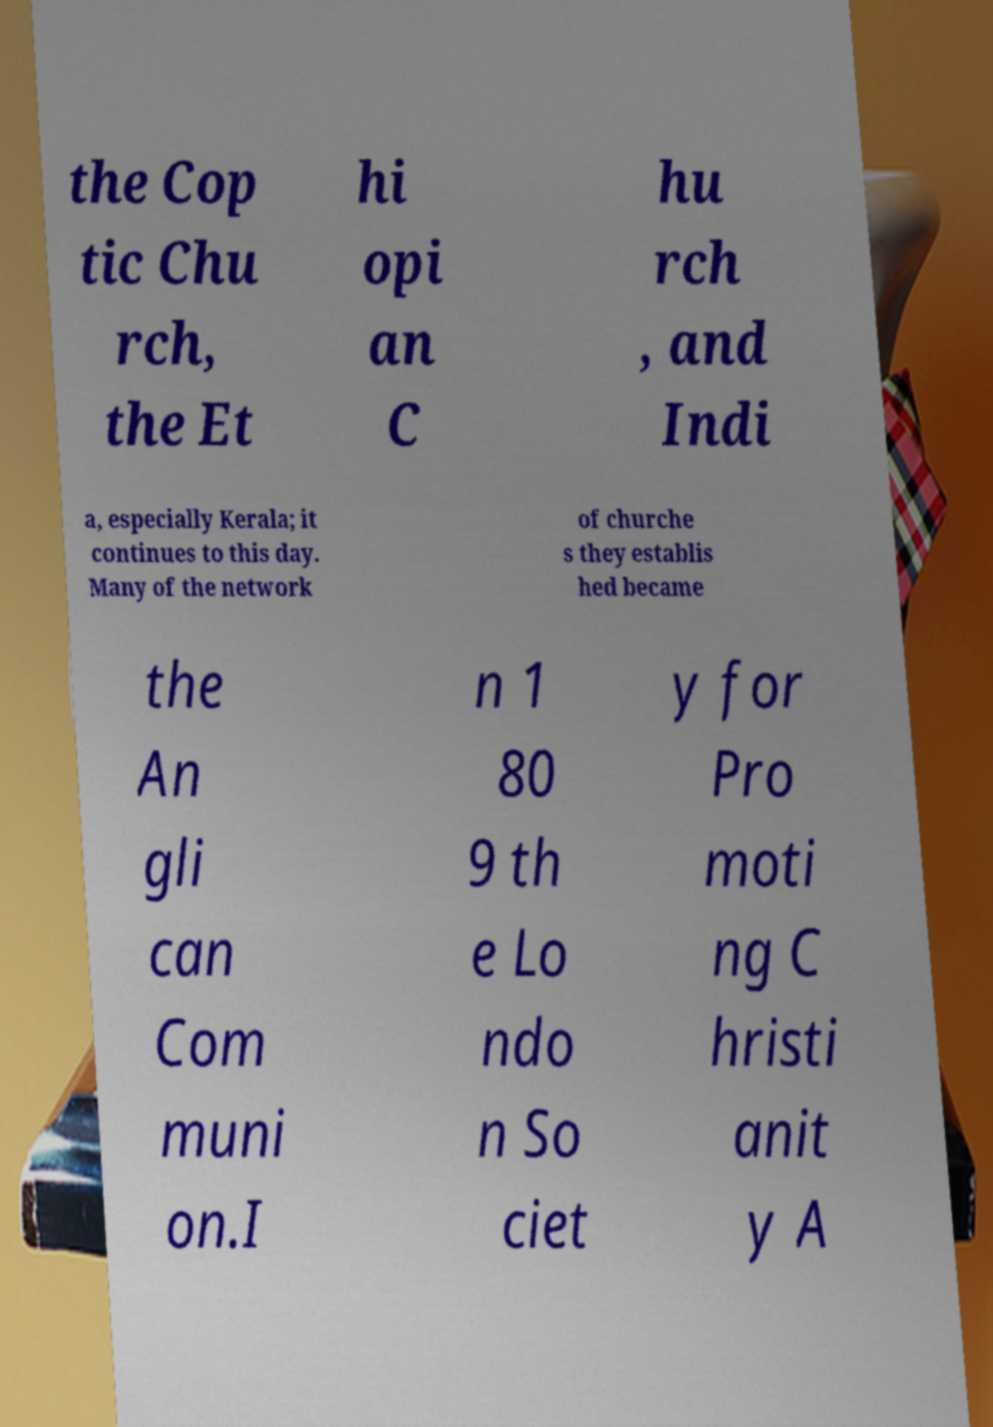Can you read and provide the text displayed in the image?This photo seems to have some interesting text. Can you extract and type it out for me? the Cop tic Chu rch, the Et hi opi an C hu rch , and Indi a, especially Kerala; it continues to this day. Many of the network of churche s they establis hed became the An gli can Com muni on.I n 1 80 9 th e Lo ndo n So ciet y for Pro moti ng C hristi anit y A 